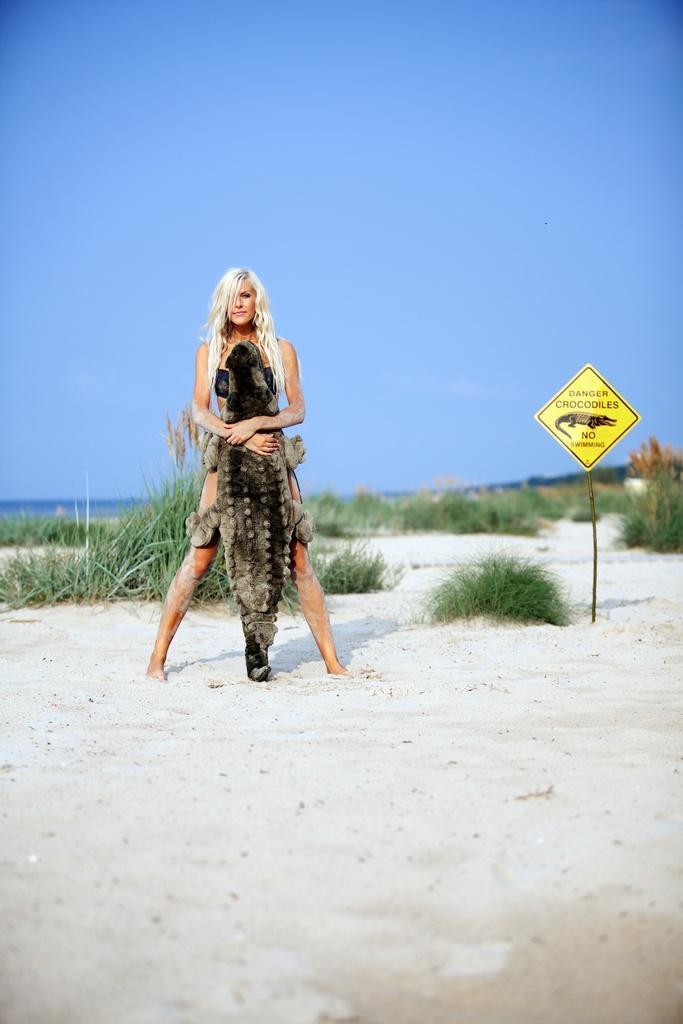Describe this image in one or two sentences. In the foreground of this picture, there is a woman standing on the sand and holding a toy crocodile in her hand. In the background, there is a sign board, grass, sand, water, and the sky. 